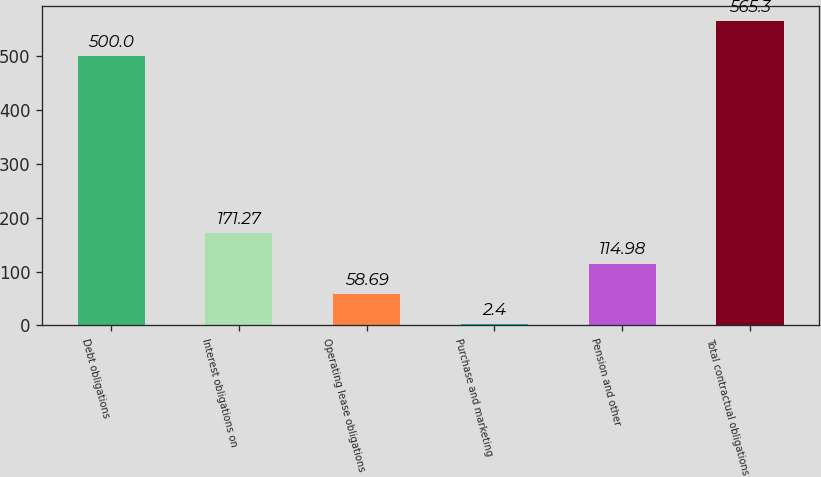Convert chart to OTSL. <chart><loc_0><loc_0><loc_500><loc_500><bar_chart><fcel>Debt obligations<fcel>Interest obligations on<fcel>Operating lease obligations<fcel>Purchase and marketing<fcel>Pension and other<fcel>Total contractual obligations<nl><fcel>500<fcel>171.27<fcel>58.69<fcel>2.4<fcel>114.98<fcel>565.3<nl></chart> 